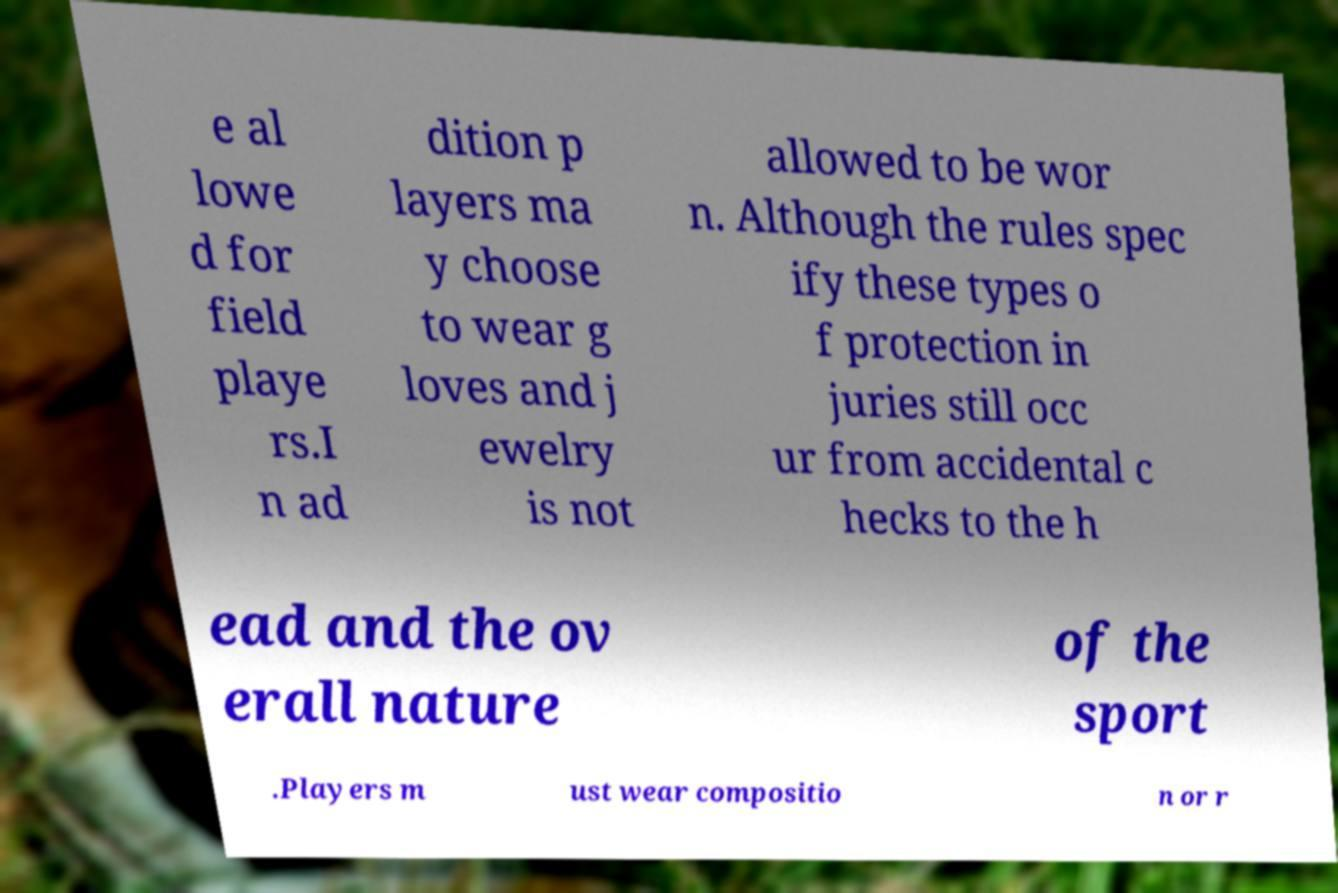Please read and relay the text visible in this image. What does it say? e al lowe d for field playe rs.I n ad dition p layers ma y choose to wear g loves and j ewelry is not allowed to be wor n. Although the rules spec ify these types o f protection in juries still occ ur from accidental c hecks to the h ead and the ov erall nature of the sport .Players m ust wear compositio n or r 